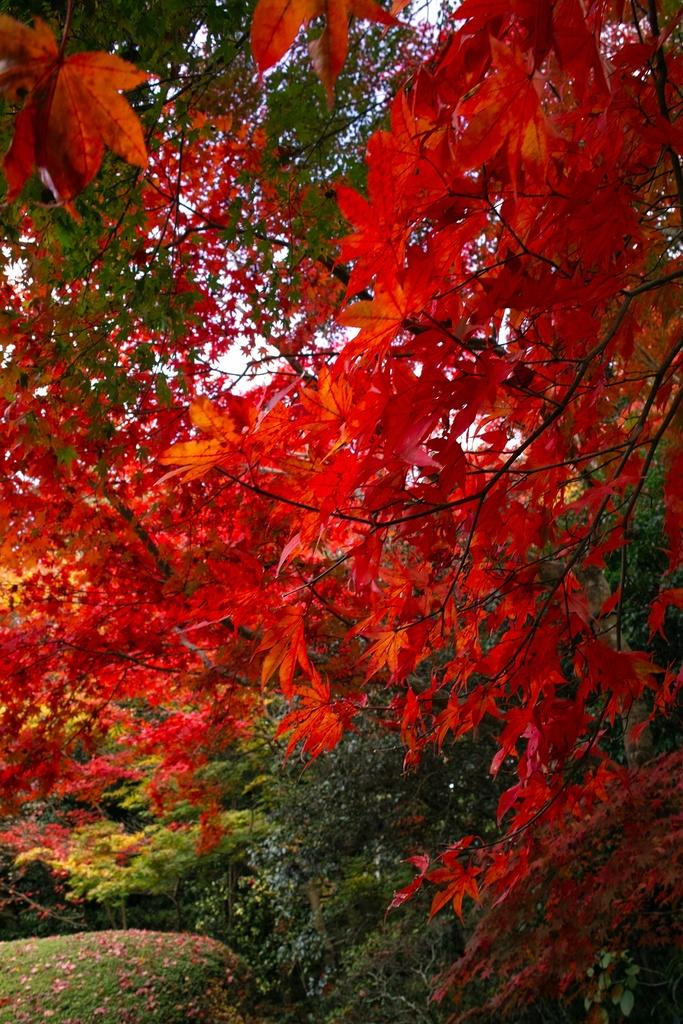What color are the leaves in the foreground of the image? The leaves in the foreground of the image are red colored. What can be seen in the background of the image? There are trees visible in the background of the image. What type of underwear is hanging from the branches of the trees in the image? There is no underwear present in the image; it only features red colored leaves in the foreground and trees in the background. 